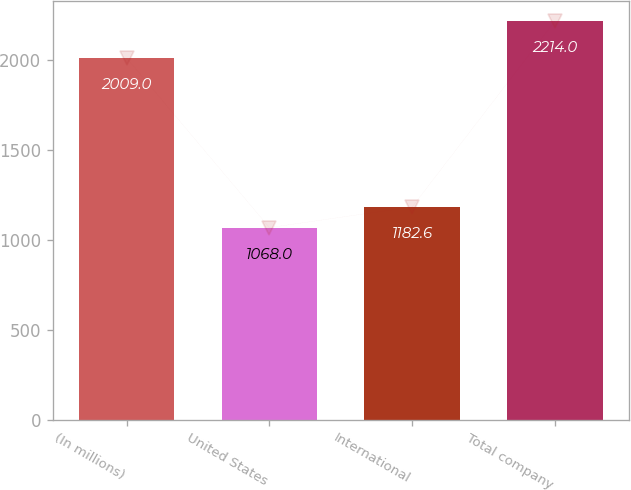Convert chart to OTSL. <chart><loc_0><loc_0><loc_500><loc_500><bar_chart><fcel>(In millions)<fcel>United States<fcel>International<fcel>Total company<nl><fcel>2009<fcel>1068<fcel>1182.6<fcel>2214<nl></chart> 